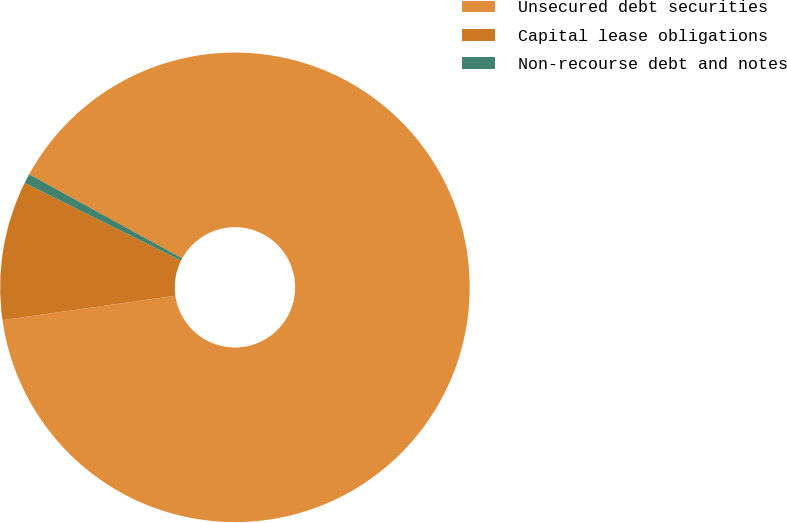Convert chart to OTSL. <chart><loc_0><loc_0><loc_500><loc_500><pie_chart><fcel>Unsecured debt securities<fcel>Capital lease obligations<fcel>Non-recourse debt and notes<nl><fcel>89.78%<fcel>9.57%<fcel>0.66%<nl></chart> 